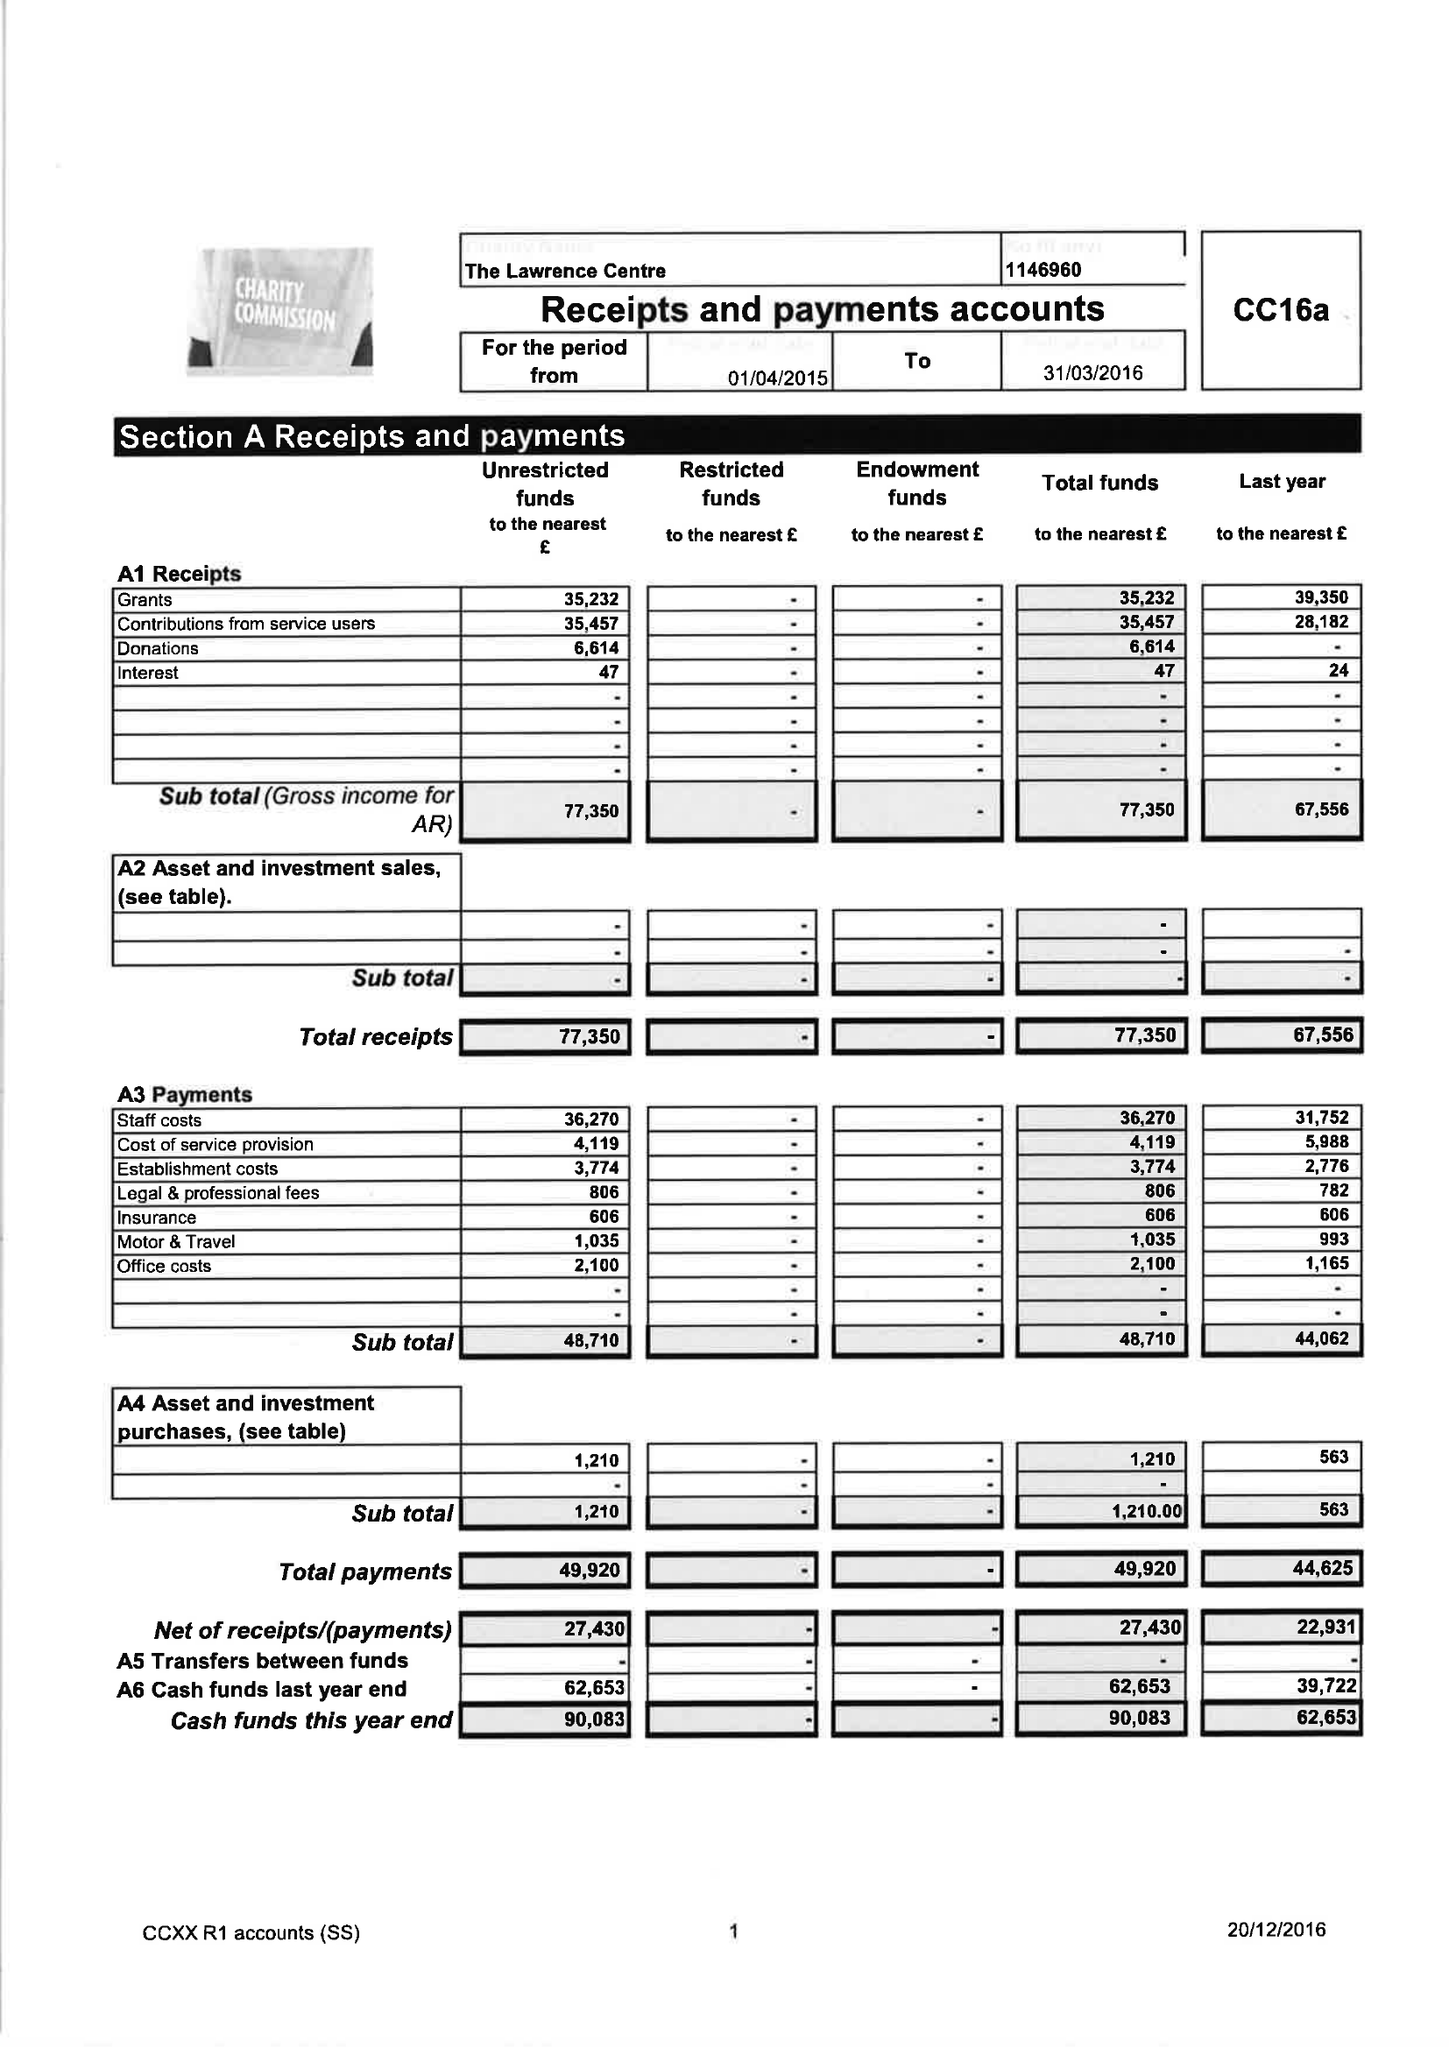What is the value for the address__postcode?
Answer the question using a single word or phrase. BA5 2PF 